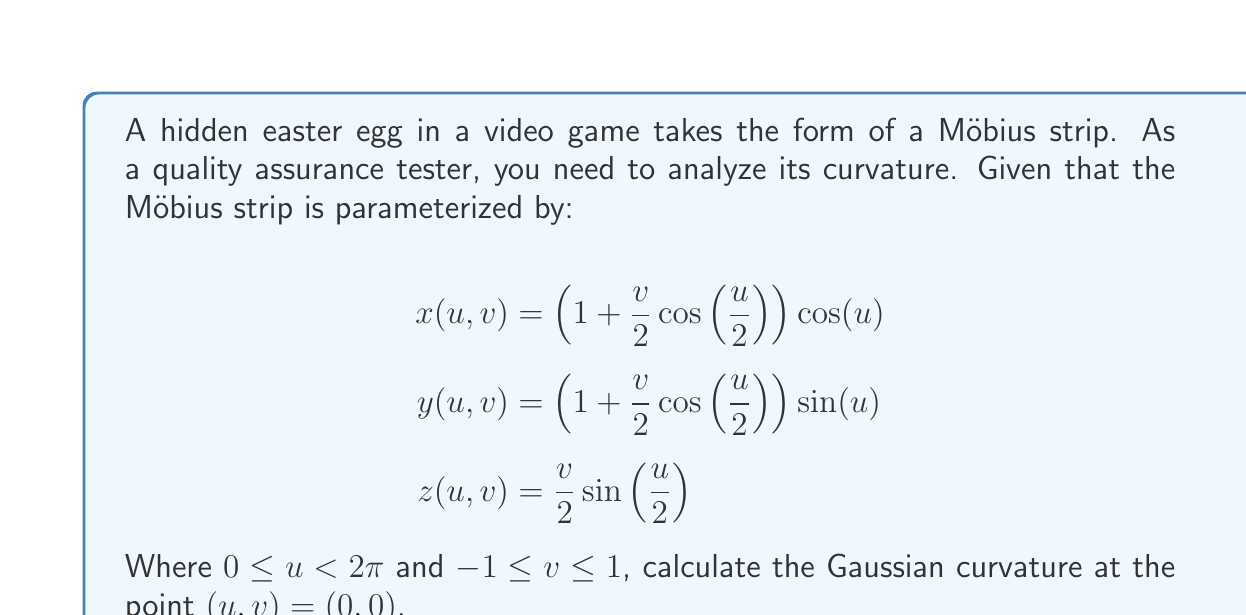Can you answer this question? To find the Gaussian curvature, we need to follow these steps:

1) Calculate the first fundamental form coefficients:
   $E = \langle x_u, x_u \rangle$, $F = \langle x_u, x_v \rangle$, $G = \langle x_v, x_v \rangle$

2) Calculate the second fundamental form coefficients:
   $e = \langle x_{uu}, N \rangle$, $f = \langle x_{uv}, N \rangle$, $g = \langle x_{vv}, N \rangle$
   Where $N$ is the unit normal vector.

3) The Gaussian curvature is then given by:
   $K = \frac{eg-f^2}{EG-F^2}$

Let's calculate each step:

1) First derivatives:
   $x_u = (-\frac{v}{4}\sin(\frac{u}{2}))\cos(u) - (1 + \frac{v}{2}\cos(\frac{u}{2}))\sin(u)$
   $x_v = \frac{1}{2}\cos(\frac{u}{2})\cos(u)$
   $y_u = (-\frac{v}{4}\sin(\frac{u}{2}))\sin(u) + (1 + \frac{v}{2}\cos(\frac{u}{2}))\cos(u)$
   $y_v = \frac{1}{2}\cos(\frac{u}{2})\sin(u)$
   $z_u = \frac{v}{4}\cos(\frac{u}{2})$
   $z_v = \frac{1}{2}\sin(\frac{u}{2})$

   At $(0,0)$:
   $x_u = -\sin(0) = 0$, $x_v = \frac{1}{2}$
   $y_u = \cos(0) = 1$, $y_v = 0$
   $z_u = 0$, $z_v = 0$

   Therefore:
   $E = 1$, $F = 0$, $G = \frac{1}{4}$

2) Second derivatives:
   $x_{uu} = (-\frac{v}{8}\cos(\frac{u}{2}))\cos(u) + (\frac{v}{2}\sin(\frac{u}{2}))\sin(u) - 2(-\frac{v}{4}\sin(\frac{u}{2}))\sin(u) - (1 + \frac{v}{2}\cos(\frac{u}{2}))\cos(u)$
   $x_{uv} = -\frac{1}{4}\sin(\frac{u}{2})\cos(u) - \frac{1}{2}\cos(\frac{u}{2})\sin(u)$
   $x_{vv} = 0$

   At $(0,0)$:
   $x_{uu} = -1$, $x_{uv} = 0$, $x_{vv} = 0$
   $y_{uu} = 0$, $y_{uv} = \frac{1}{2}$, $y_{vv} = 0$
   $z_{uu} = 0$, $z_{uv} = \frac{1}{4}$, $z_{vv} = 0$

   The unit normal vector at $(0,0)$ is:
   $N = \frac{x_u \times x_v}{|x_u \times x_v|} = (0, 0, 1)$

   Therefore:
   $e = -1$, $f = \frac{1}{4}$, $g = 0$

3) Calculating the Gaussian curvature:
   $K = \frac{eg-f^2}{EG-F^2} = \frac{(-1)(0)-(\frac{1}{4})^2}{(1)(\frac{1}{4})-(0)^2} = -\frac{1/16}{1/4} = -\frac{1}{4}$
Answer: $-\frac{1}{4}$ 